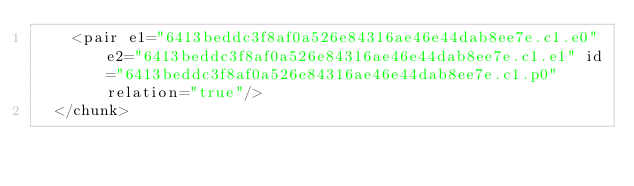Convert code to text. <code><loc_0><loc_0><loc_500><loc_500><_XML_>    <pair e1="6413beddc3f8af0a526e84316ae46e44dab8ee7e.c1.e0" e2="6413beddc3f8af0a526e84316ae46e44dab8ee7e.c1.e1" id="6413beddc3f8af0a526e84316ae46e44dab8ee7e.c1.p0" relation="true"/>
  </chunk></code> 